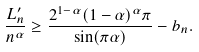Convert formula to latex. <formula><loc_0><loc_0><loc_500><loc_500>\frac { L _ { n } ^ { \prime } } { n ^ { \alpha } } \geq \frac { 2 ^ { 1 - \alpha } ( 1 - \alpha ) ^ { \alpha } \pi } { \sin ( \pi \alpha ) } - b _ { n } .</formula> 